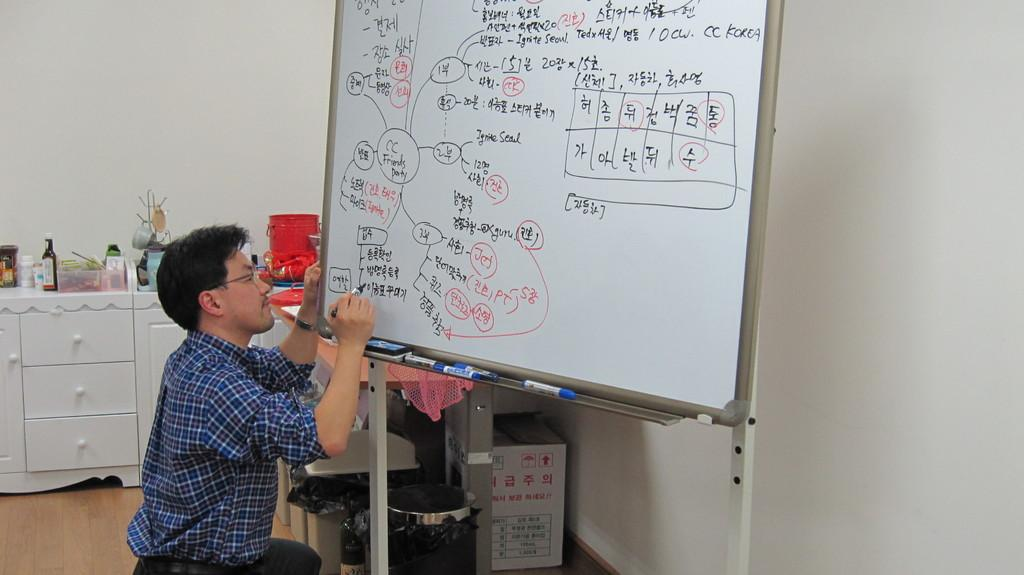<image>
Write a terse but informative summary of the picture. Person writing on a whiteboard that says korean words on it. 